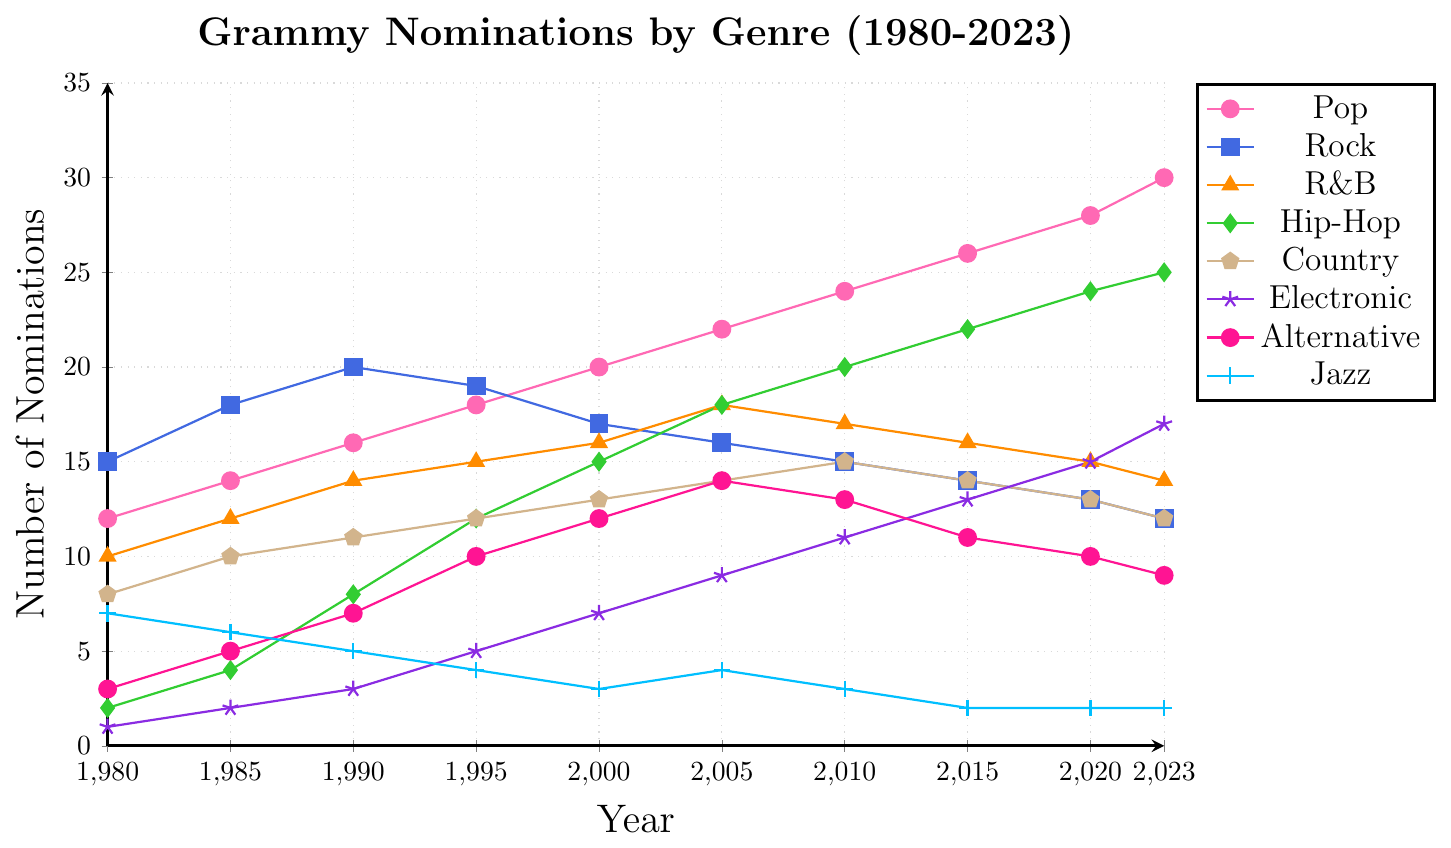What's the trend of Grammy nominations for the Hip-Hop genre from 1980 to 2023? Observing the Hip-Hop curve (green), it shows a continuous upward trend from 2 nominations in 1980 to 25 nominations in 2023.
Answer: It's an increasing trend Which genre had the most nominations in 1985? By looking at the 1985 data point, Rock (blue) had 18 nominations, which is higher than any other genre that year.
Answer: Rock Did the number of Pop nominations ever decrease between any consecutive years? The number of Pop nominations (pink) increases steadily from 12 in 1980 to 30 in 2023 without any decrease at any point.
Answer: No Which genre had the sharpest increase in nominations between 1980 and 2023? Hip-Hop (green) had the sharpest increase, going from 2 nominations in 1980 to 25 nominations in 2023, a total increase of 23 nominations.
Answer: Hip-Hop What is the difference in Jazz nominations between 1980 and 2023? The Jazz genre (light blue) had 7 nominations in 1980 and 2 nominations in 2023. The difference is 7 - 2 = 5 nominations.
Answer: 5 How many more nominations did Electronic music have in 2023 compared to 1980? Electronic (purple) had 1 nomination in 1980 and 17 nominations in 2023. The difference is 17 - 1 = 16 nominations.
Answer: 16 What is the average number of Rock nominations from 1980 to 2023? Adding up Rock nominations from each year: 15 + 18 + 20 + 19 + 17 + 16 + 15 + 14 + 13 + 12 = 159. The average is 159 / 10 = 15.9
Answer: 15.9 Which genre saw a decline in nominations from 1990 to 2023? The genres that declined include Rock (from 20 to 12), Alternative (from 7 to 9), and Jazz (from 5 to 2). Notable decline for Rock.
Answer: Rock Compare the number of nominations for Pop and Country in 2023. Which one had more, and by how many? In 2023, Pop (pink) had 30 nominations and Country (brown) had 12 nominations. The difference is 30 - 12 = 18.
Answer: Pop, by 18 Calculate the overall increase in nominations for the Electronic genre from 1980 to 2023. Electronic had 1 nomination in 1980 and 17 in 2023. The increase is 17 - 1 = 16 nominations.
Answer: 16 What is the trend of Alternative genre nominations from 1980 to 2023? The Alternative genre generally increased from 3 nominations in 1980 to a peak of 14 in 2005, but then decreased to 9 nominations in 2023.
Answer: Increase then decrease 